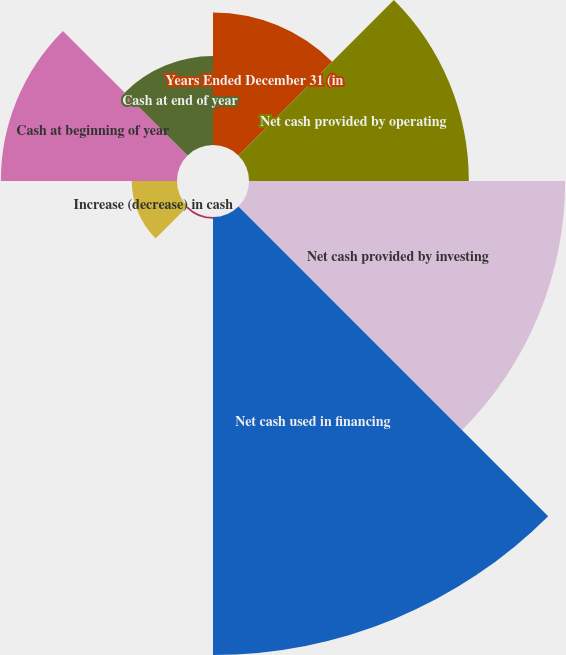Convert chart. <chart><loc_0><loc_0><loc_500><loc_500><pie_chart><fcel>Years Ended December 31 (in<fcel>Net cash provided by operating<fcel>Net cash provided by investing<fcel>Net cash used in financing<fcel>Effect of exchange rate<fcel>Increase (decrease) in cash<fcel>Cash at beginning of year<fcel>Cash at end of year<nl><fcel>9.34%<fcel>15.5%<fcel>22.29%<fcel>30.88%<fcel>0.12%<fcel>3.19%<fcel>12.42%<fcel>6.27%<nl></chart> 